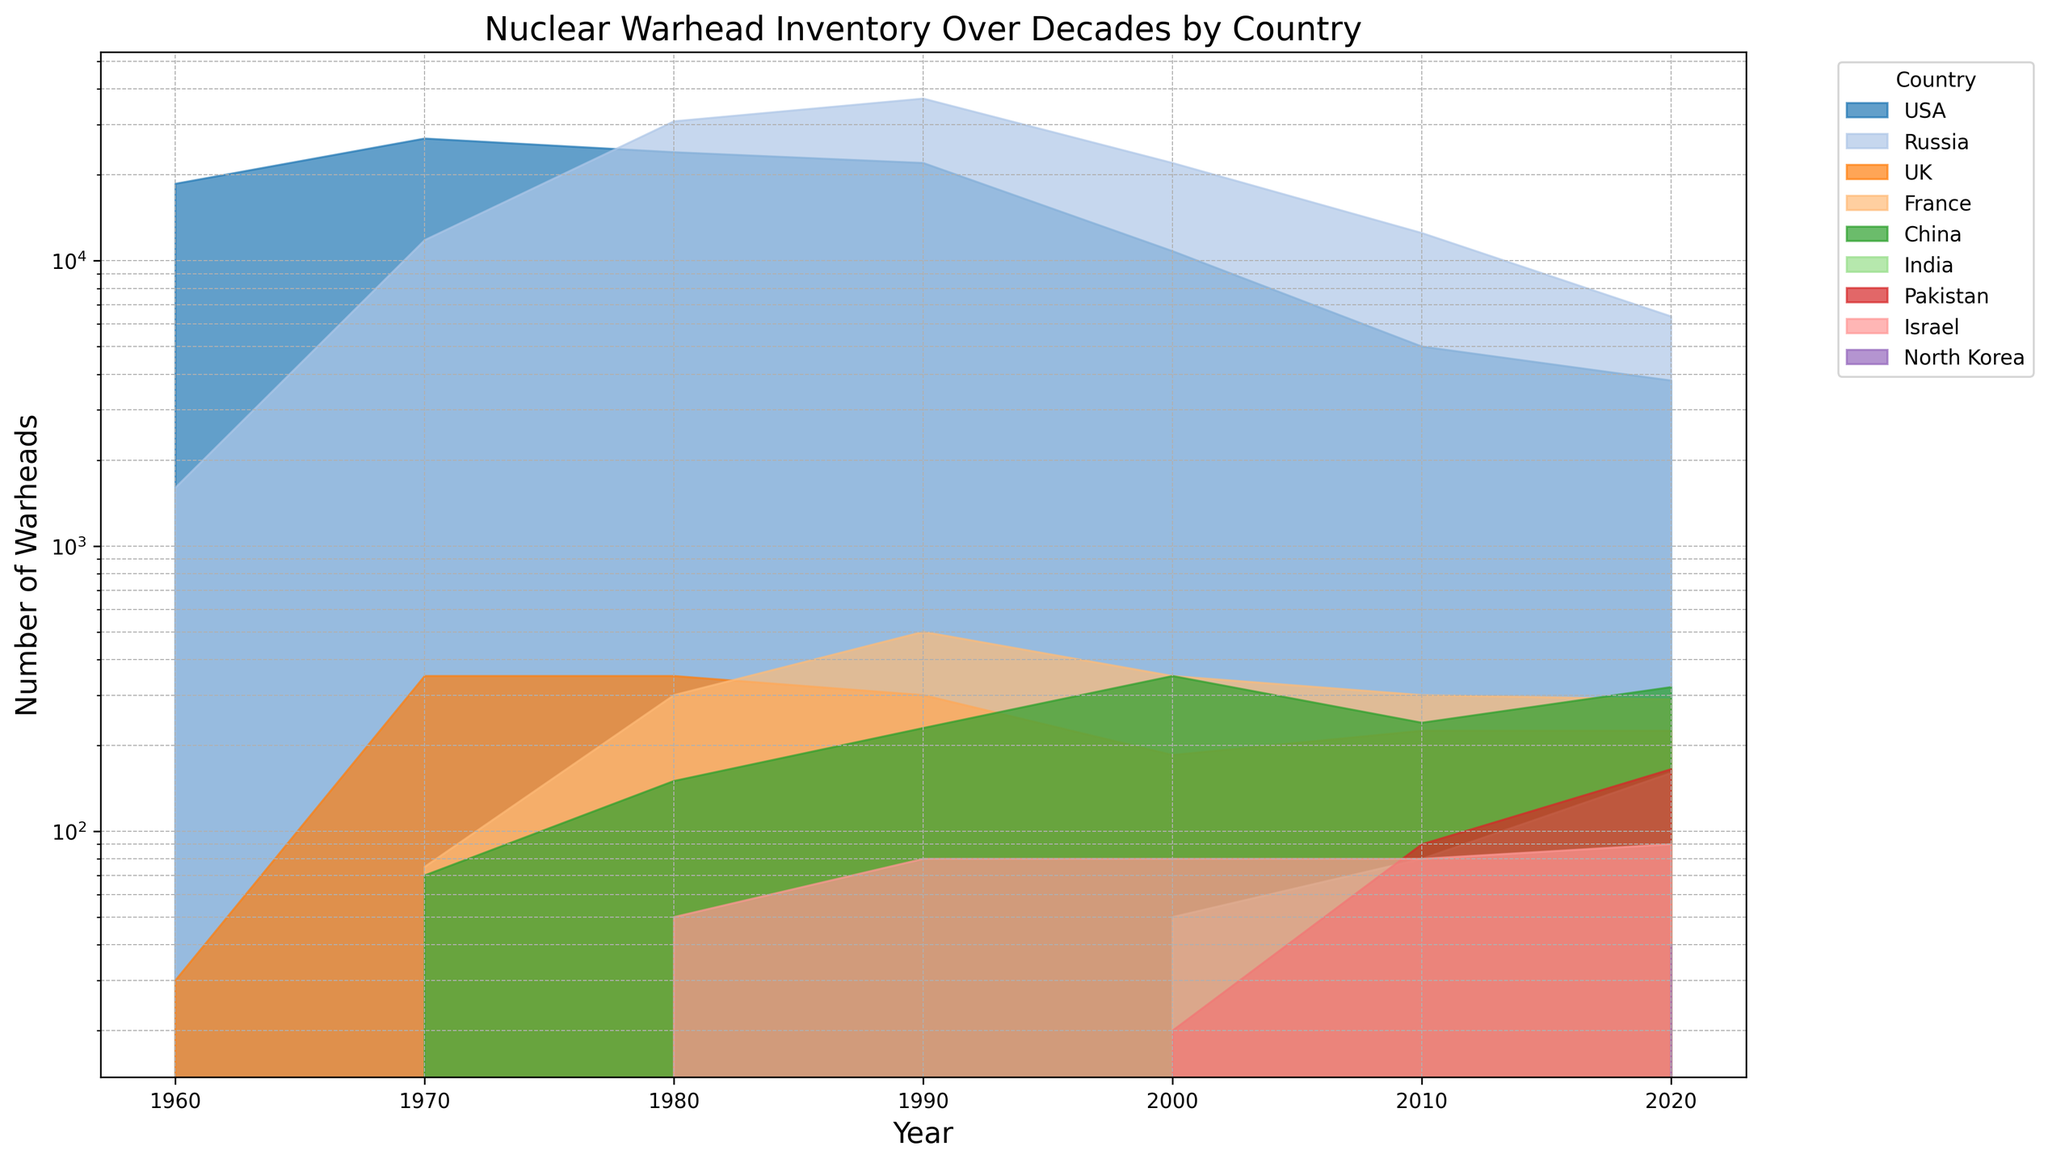Which country had the highest number of nuclear warheads in 1990? Inspect the peaks of the area chart for the year 1990. Russia’s area is the highest, indicating the largest inventory of nuclear warheads.
Answer: Russia How did the number of nuclear warheads for the USA change between 1980 and 2020? Look at the USA area's values in 1980 and 2020. The value decreased from 24,000 to 3,800.
Answer: Decreased Which two countries had a roughly stable number of nuclear warheads from 2000 to 2020? Look for the areas with little to no vertical movement between 2000 and 2020. The UK and Israel's areas show minimal changes in their warhead counts.
Answer: UK, Israel By how much did Russia's nuclear warheads decrease from 1990 to 2020? Subtract Russia’s warhead count in 2020 from its count in 1990; 37,000 in 1990 and 6,375 in 2020. Decrease = 37,000 - 6,375.
Answer: 30,625 Which country had an increase in nuclear warheads between 2010 and 2020 and by how much? Look for countries where the area height increased between 2010 and 2020. India and Pakistan show increases. India’s increase = 160 - 80, and Pakistan's increase = 165 - 90.
Answer: India: 80, Pakistan: 75 When did France have its peak number of nuclear warheads, and what was the value? Search for the maximum height in France's area. The peak was around 1990 with 500 warheads.
Answer: 1990, 500 What were the nuclear warhead counts of the UK and China in 2000, and which was higher? Compare the values in 2000 for both countries. The UK had 185, and China had 350. China’s count was higher.
Answer: UK: 185, China: 350, China Which country observed the smallest increase in nuclear warheads from their initial count to 2020? Calculate the differences for countries with initial counts greater than zero. Initial for France (0 to 290), initial for Russia (1,600 to 6,375). France had the smallest increase: 290 - 0 = 290.
Answer: France By how much did China's nuclear warhead count change from 1970 to 2000? Find China’s counts in 1970 (70) and 2000 (350), and calculate the difference: 350 - 70.
Answer: 280 Which countries had zero nuclear warheads in 1960? Find the zeros in the area chart for the year 1960. France, China, India, Pakistan, Israel, and North Korea had zero warheads in 1960.
Answer: France, China, India, Pakistan, Israel, North Korea 